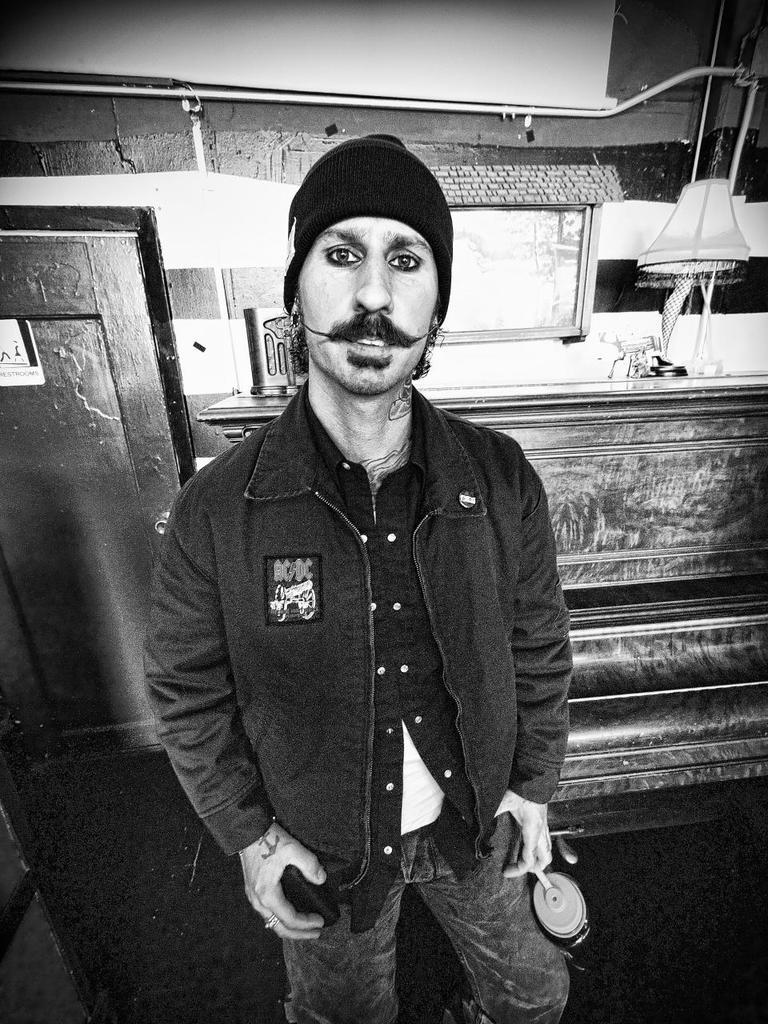Who or what is present in the image? There is a person in the image. What is the person wearing on their head? The person is wearing a cap. What object can be seen providing light in the image? There is a lamp in the image. What feature is present that might allow access to another room or area? There is a door in the image. What type of tiger can be seen in the image? There is no tiger present in the image. 